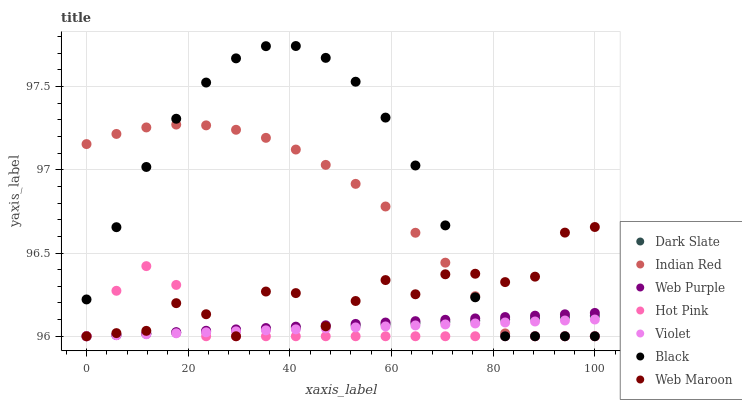Does Violet have the minimum area under the curve?
Answer yes or no. Yes. Does Black have the maximum area under the curve?
Answer yes or no. Yes. Does Web Maroon have the minimum area under the curve?
Answer yes or no. No. Does Web Maroon have the maximum area under the curve?
Answer yes or no. No. Is Dark Slate the smoothest?
Answer yes or no. Yes. Is Web Maroon the roughest?
Answer yes or no. Yes. Is Web Maroon the smoothest?
Answer yes or no. No. Is Dark Slate the roughest?
Answer yes or no. No. Does Hot Pink have the lowest value?
Answer yes or no. Yes. Does Black have the highest value?
Answer yes or no. Yes. Does Web Maroon have the highest value?
Answer yes or no. No. Does Indian Red intersect Dark Slate?
Answer yes or no. Yes. Is Indian Red less than Dark Slate?
Answer yes or no. No. Is Indian Red greater than Dark Slate?
Answer yes or no. No. 